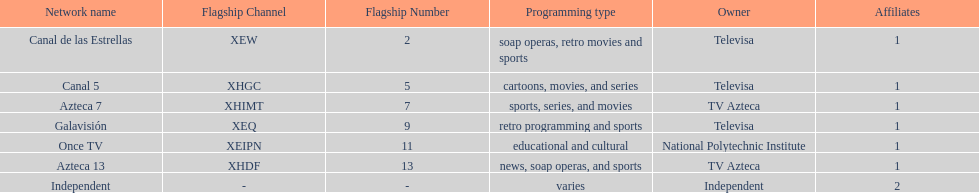How many networks do not air sports? 2. 